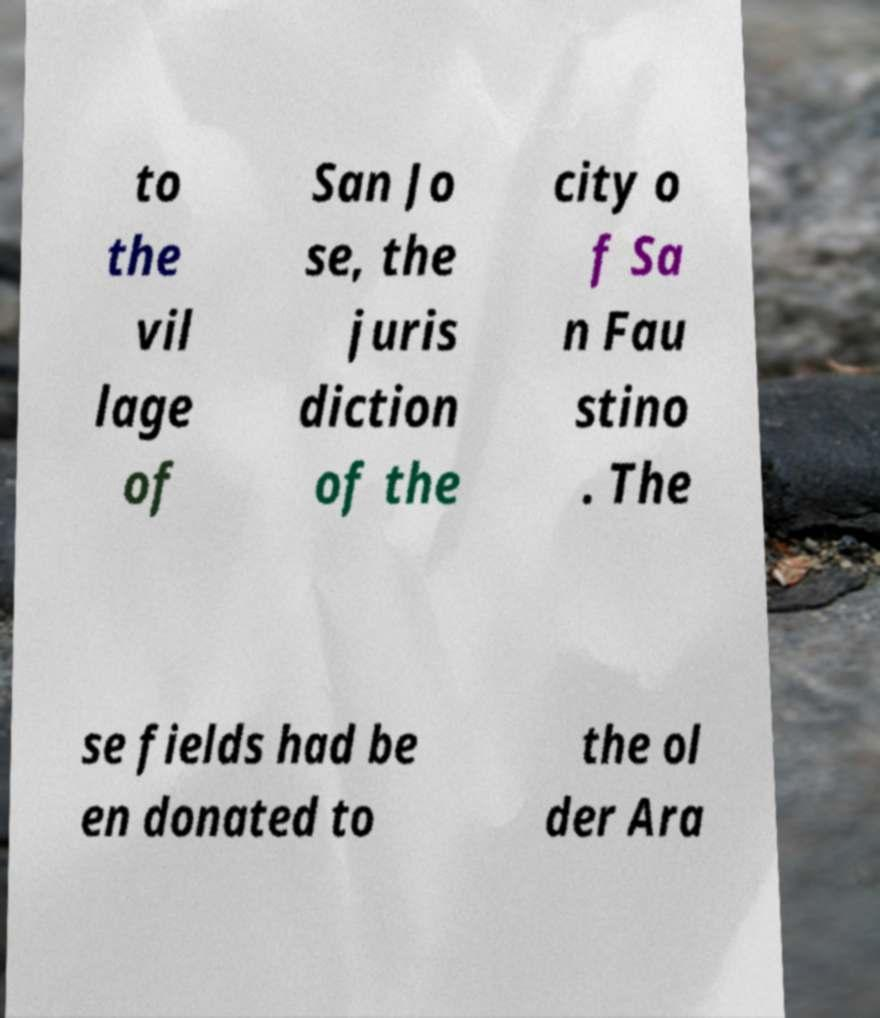Could you assist in decoding the text presented in this image and type it out clearly? to the vil lage of San Jo se, the juris diction of the city o f Sa n Fau stino . The se fields had be en donated to the ol der Ara 